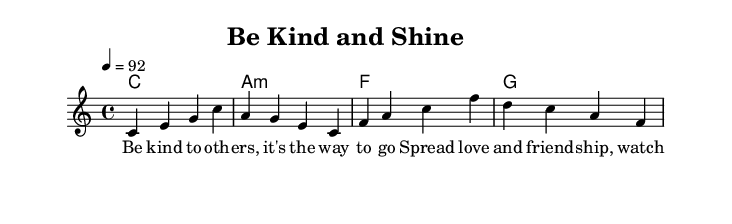What is the key signature of this music? The key signature shown in the score is C major, indicated by the absence of sharps or flats in the leftmost part of the sheet music.
Answer: C major What is the time signature of the piece? The time signature is found at the beginning of the staff, and it is displayed as 4/4, meaning there are four beats in each measure, and the quarter note gets one beat.
Answer: 4/4 What is the tempo marking? The tempo marking is indicated by the number 92, which appears at the beginning of the score, meaning the piece should be played at a speed of 92 beats per minute.
Answer: 92 How many measures are in the melody? By counting the distinct units of structured music notation within the melody section, you can see that there are four measures based on the grouping of notes.
Answer: Four What type of chords are used in the harmonies? The chords indicated in the harmonies section are C major, A minor, F major, and G major, which are typical chord types in Western music.
Answer: Major and minor What moral lesson does the song convey? Referring to the lyrics provided, the song conveys a message about kindness and friendship, suggesting that these values help relationships grow.
Answer: Kindness and friendship How does the structure support the rap genre? The rhythmic and lyrical components are designed to emphasize delivery and flow characteristic of rap, including a catchy repetitive motif to engage young listeners.
Answer: Rhythmic and lyrical emphasis 